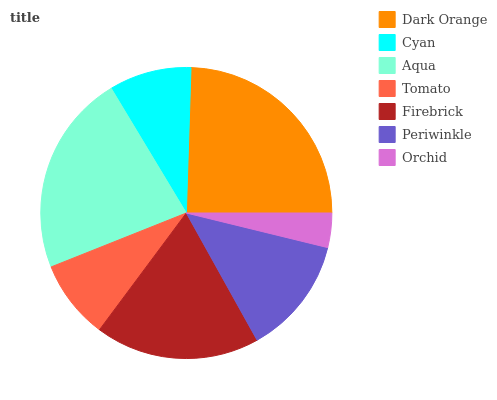Is Orchid the minimum?
Answer yes or no. Yes. Is Dark Orange the maximum?
Answer yes or no. Yes. Is Cyan the minimum?
Answer yes or no. No. Is Cyan the maximum?
Answer yes or no. No. Is Dark Orange greater than Cyan?
Answer yes or no. Yes. Is Cyan less than Dark Orange?
Answer yes or no. Yes. Is Cyan greater than Dark Orange?
Answer yes or no. No. Is Dark Orange less than Cyan?
Answer yes or no. No. Is Periwinkle the high median?
Answer yes or no. Yes. Is Periwinkle the low median?
Answer yes or no. Yes. Is Orchid the high median?
Answer yes or no. No. Is Cyan the low median?
Answer yes or no. No. 